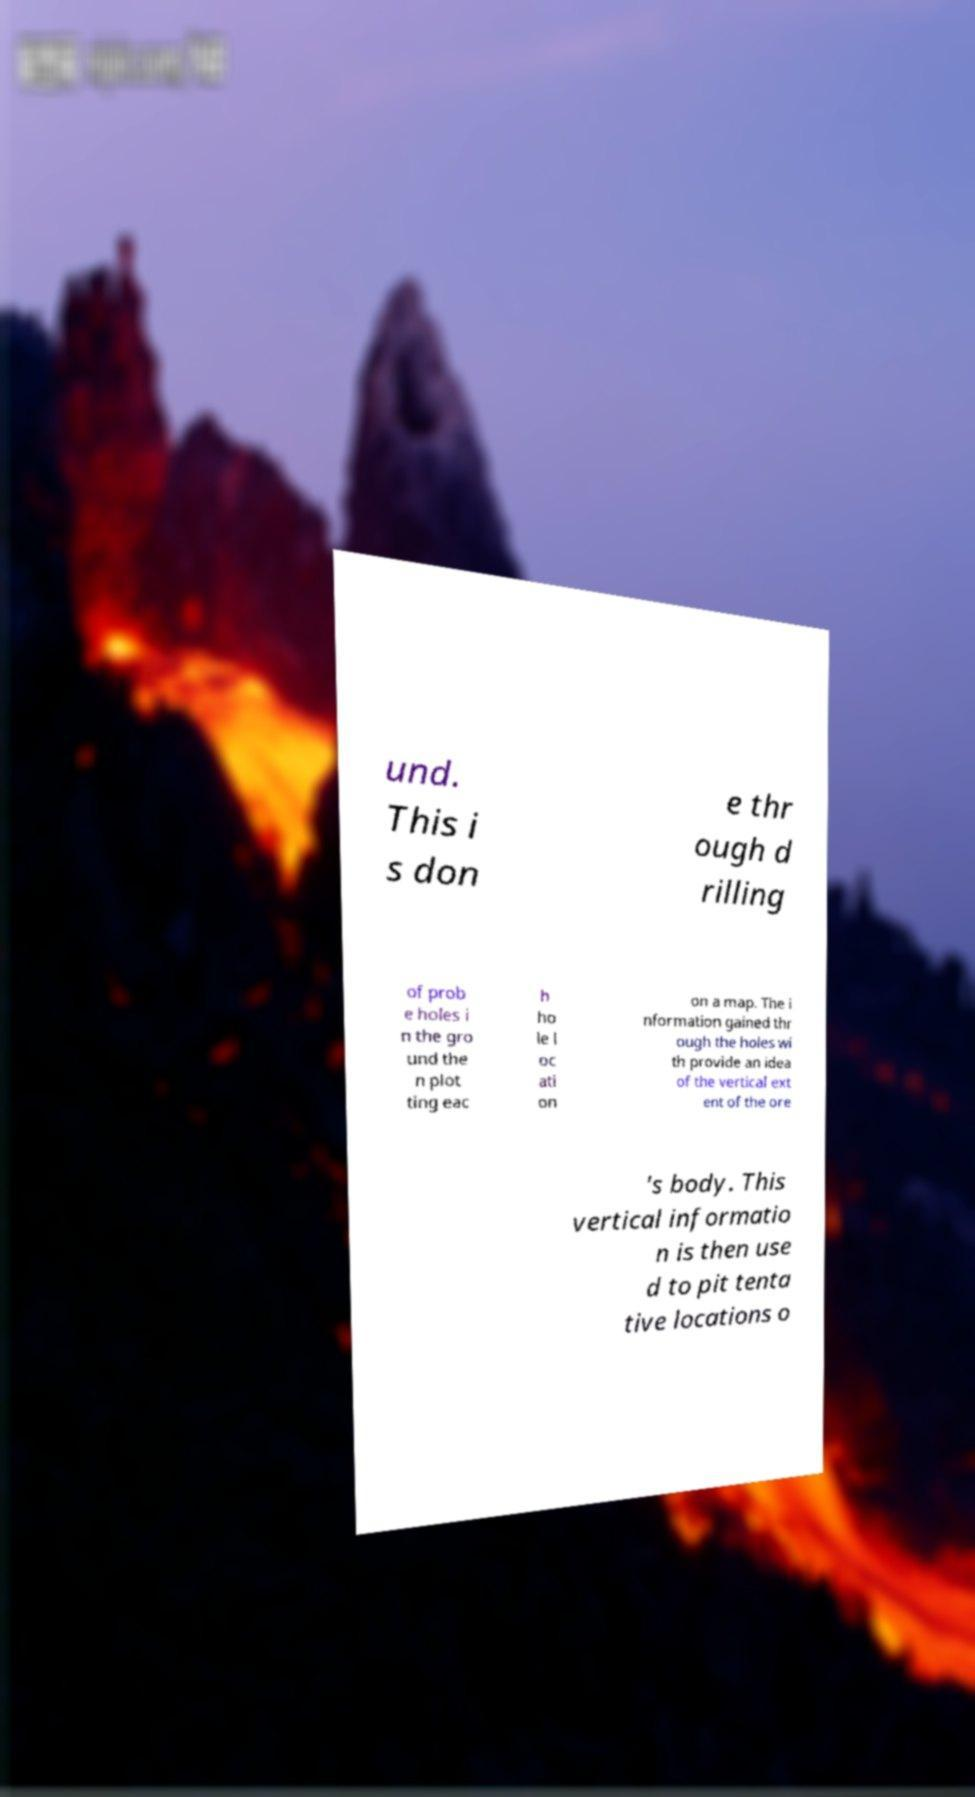I need the written content from this picture converted into text. Can you do that? und. This i s don e thr ough d rilling of prob e holes i n the gro und the n plot ting eac h ho le l oc ati on on a map. The i nformation gained thr ough the holes wi th provide an idea of the vertical ext ent of the ore 's body. This vertical informatio n is then use d to pit tenta tive locations o 